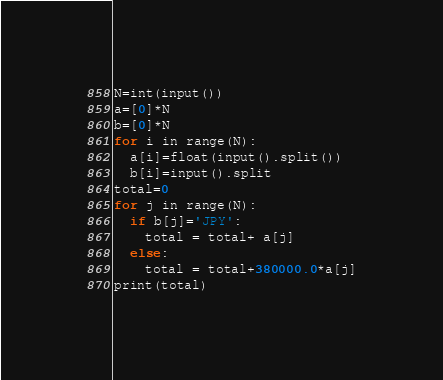Convert code to text. <code><loc_0><loc_0><loc_500><loc_500><_Python_>N=int(input())
a=[0]*N
b=[0]*N
for i in range(N):
  a[i]=float(input().split())
  b[i]=input().split
total=0
for j in range(N):
  if b[j]='JPY':
    total = total+ a[j]
  else:
    total = total+380000.0*a[j]
print(total)
</code> 